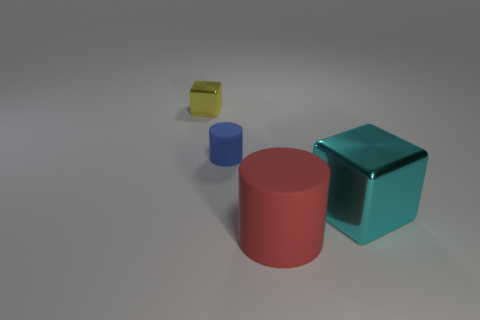Add 1 brown shiny objects. How many objects exist? 5 Add 3 tiny rubber balls. How many tiny rubber balls exist? 3 Subtract 0 red blocks. How many objects are left? 4 Subtract all green matte balls. Subtract all red things. How many objects are left? 3 Add 1 cylinders. How many cylinders are left? 3 